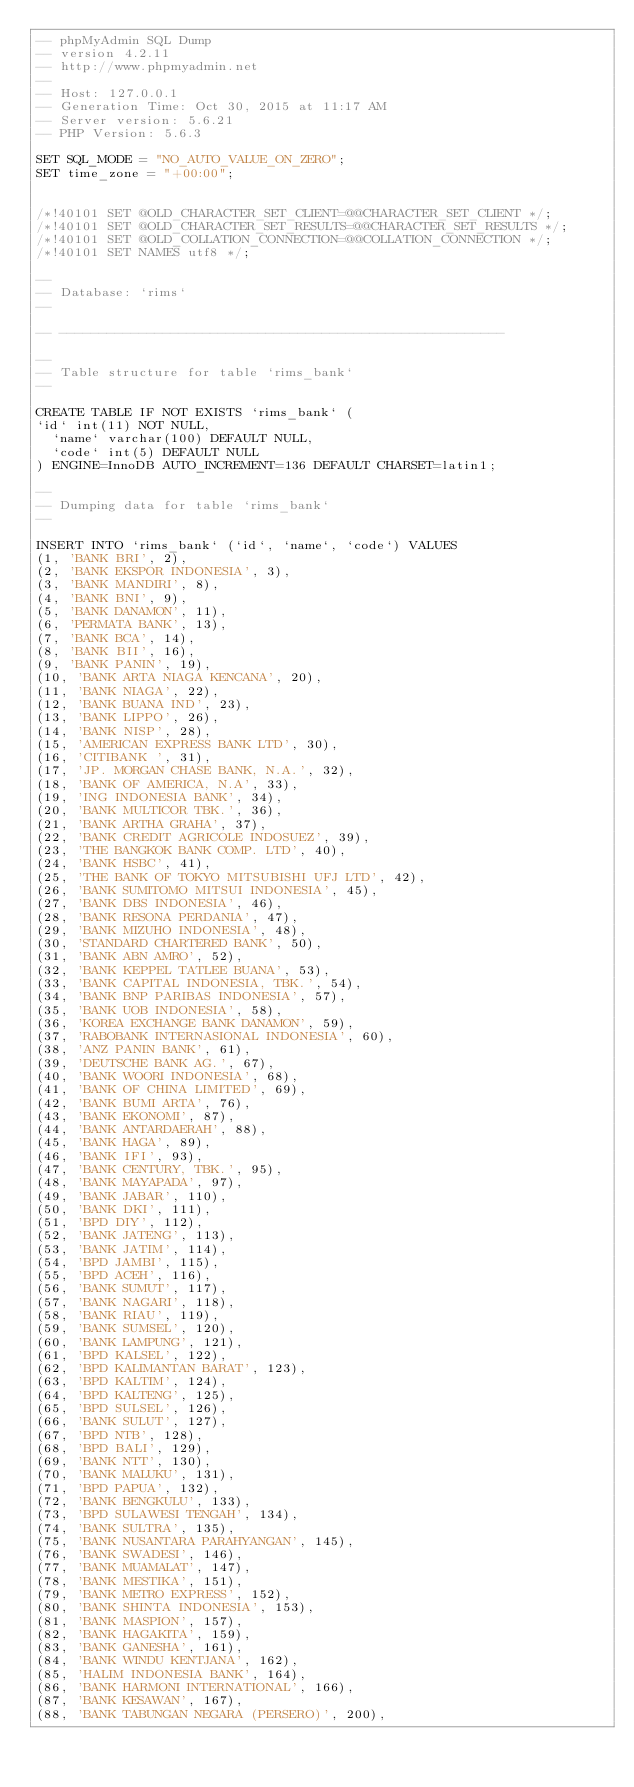Convert code to text. <code><loc_0><loc_0><loc_500><loc_500><_SQL_>-- phpMyAdmin SQL Dump
-- version 4.2.11
-- http://www.phpmyadmin.net
--
-- Host: 127.0.0.1
-- Generation Time: Oct 30, 2015 at 11:17 AM
-- Server version: 5.6.21
-- PHP Version: 5.6.3

SET SQL_MODE = "NO_AUTO_VALUE_ON_ZERO";
SET time_zone = "+00:00";


/*!40101 SET @OLD_CHARACTER_SET_CLIENT=@@CHARACTER_SET_CLIENT */;
/*!40101 SET @OLD_CHARACTER_SET_RESULTS=@@CHARACTER_SET_RESULTS */;
/*!40101 SET @OLD_COLLATION_CONNECTION=@@COLLATION_CONNECTION */;
/*!40101 SET NAMES utf8 */;

--
-- Database: `rims`
--

-- --------------------------------------------------------

--
-- Table structure for table `rims_bank`
--

CREATE TABLE IF NOT EXISTS `rims_bank` (
`id` int(11) NOT NULL,
  `name` varchar(100) DEFAULT NULL,
  `code` int(5) DEFAULT NULL
) ENGINE=InnoDB AUTO_INCREMENT=136 DEFAULT CHARSET=latin1;

--
-- Dumping data for table `rims_bank`
--

INSERT INTO `rims_bank` (`id`, `name`, `code`) VALUES
(1, 'BANK BRI', 2),
(2, 'BANK EKSPOR INDONESIA', 3),
(3, 'BANK MANDIRI', 8),
(4, 'BANK BNI', 9),
(5, 'BANK DANAMON', 11),
(6, 'PERMATA BANK', 13),
(7, 'BANK BCA', 14),
(8, 'BANK BII', 16),
(9, 'BANK PANIN', 19),
(10, 'BANK ARTA NIAGA KENCANA', 20),
(11, 'BANK NIAGA', 22),
(12, 'BANK BUANA IND', 23),
(13, 'BANK LIPPO', 26),
(14, 'BANK NISP', 28),
(15, 'AMERICAN EXPRESS BANK LTD', 30),
(16, 'CITIBANK ', 31),
(17, 'JP. MORGAN CHASE BANK, N.A.', 32),
(18, 'BANK OF AMERICA, N.A', 33),
(19, 'ING INDONESIA BANK', 34),
(20, 'BANK MULTICOR TBK.', 36),
(21, 'BANK ARTHA GRAHA', 37),
(22, 'BANK CREDIT AGRICOLE INDOSUEZ', 39),
(23, 'THE BANGKOK BANK COMP. LTD', 40),
(24, 'BANK HSBC', 41),
(25, 'THE BANK OF TOKYO MITSUBISHI UFJ LTD', 42),
(26, 'BANK SUMITOMO MITSUI INDONESIA', 45),
(27, 'BANK DBS INDONESIA', 46),
(28, 'BANK RESONA PERDANIA', 47),
(29, 'BANK MIZUHO INDONESIA', 48),
(30, 'STANDARD CHARTERED BANK', 50),
(31, 'BANK ABN AMRO', 52),
(32, 'BANK KEPPEL TATLEE BUANA', 53),
(33, 'BANK CAPITAL INDONESIA, TBK.', 54),
(34, 'BANK BNP PARIBAS INDONESIA', 57),
(35, 'BANK UOB INDONESIA', 58),
(36, 'KOREA EXCHANGE BANK DANAMON', 59),
(37, 'RABOBANK INTERNASIONAL INDONESIA', 60),
(38, 'ANZ PANIN BANK', 61),
(39, 'DEUTSCHE BANK AG.', 67),
(40, 'BANK WOORI INDONESIA', 68),
(41, 'BANK OF CHINA LIMITED', 69),
(42, 'BANK BUMI ARTA', 76),
(43, 'BANK EKONOMI', 87),
(44, 'BANK ANTARDAERAH', 88),
(45, 'BANK HAGA', 89),
(46, 'BANK IFI', 93),
(47, 'BANK CENTURY, TBK.', 95),
(48, 'BANK MAYAPADA', 97),
(49, 'BANK JABAR', 110),
(50, 'BANK DKI', 111),
(51, 'BPD DIY', 112),
(52, 'BANK JATENG', 113),
(53, 'BANK JATIM', 114),
(54, 'BPD JAMBI', 115),
(55, 'BPD ACEH', 116),
(56, 'BANK SUMUT', 117),
(57, 'BANK NAGARI', 118),
(58, 'BANK RIAU', 119),
(59, 'BANK SUMSEL', 120),
(60, 'BANK LAMPUNG', 121),
(61, 'BPD KALSEL', 122),
(62, 'BPD KALIMANTAN BARAT', 123),
(63, 'BPD KALTIM', 124),
(64, 'BPD KALTENG', 125),
(65, 'BPD SULSEL', 126),
(66, 'BANK SULUT', 127),
(67, 'BPD NTB', 128),
(68, 'BPD BALI', 129),
(69, 'BANK NTT', 130),
(70, 'BANK MALUKU', 131),
(71, 'BPD PAPUA', 132),
(72, 'BANK BENGKULU', 133),
(73, 'BPD SULAWESI TENGAH', 134),
(74, 'BANK SULTRA', 135),
(75, 'BANK NUSANTARA PARAHYANGAN', 145),
(76, 'BANK SWADESI', 146),
(77, 'BANK MUAMALAT', 147),
(78, 'BANK MESTIKA', 151),
(79, 'BANK METRO EXPRESS', 152),
(80, 'BANK SHINTA INDONESIA', 153),
(81, 'BANK MASPION', 157),
(82, 'BANK HAGAKITA', 159),
(83, 'BANK GANESHA', 161),
(84, 'BANK WINDU KENTJANA', 162),
(85, 'HALIM INDONESIA BANK', 164),
(86, 'BANK HARMONI INTERNATIONAL', 166),
(87, 'BANK KESAWAN', 167),
(88, 'BANK TABUNGAN NEGARA (PERSERO)', 200),</code> 